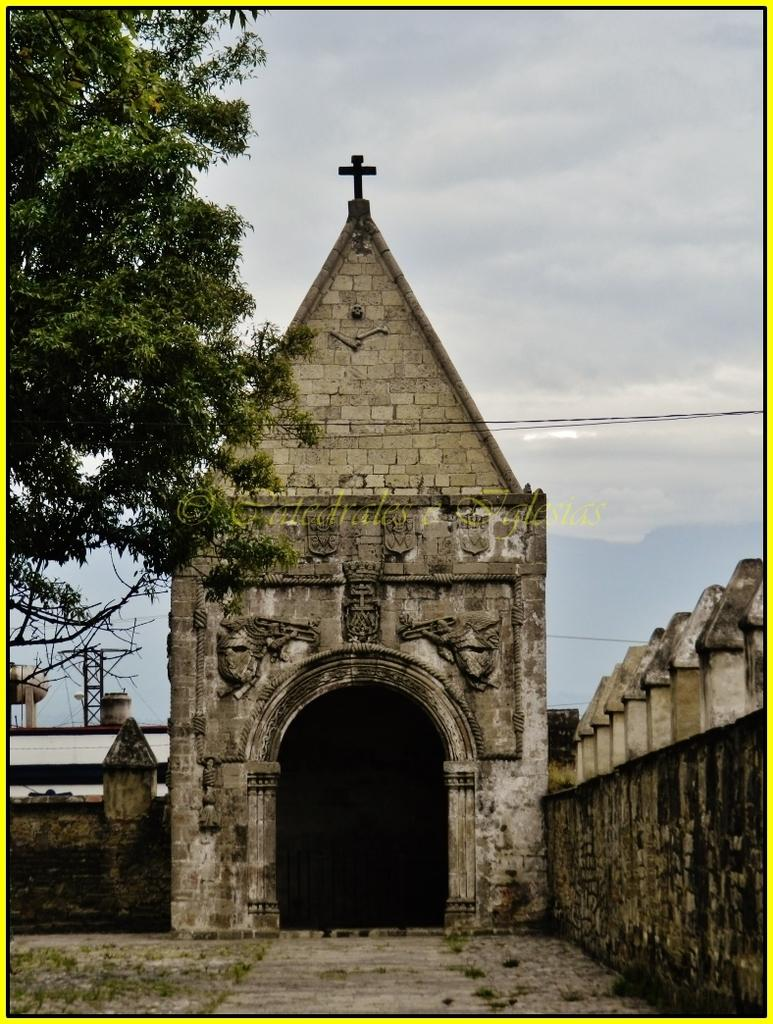What type of structure can be seen in the image? There is an arch in the image. What can be seen in the background of the image? There are metal rods, a tree, and clouds in the background of the image. Where is the text located in the image? The text is in the middle of the image. How many beds are visible in the image? There are no beds present in the image. What type of stitch is used to create the arch in the image? The image does not provide information about the type of stitch used to create the arch, as it is a photograph and not a fabric construction. 